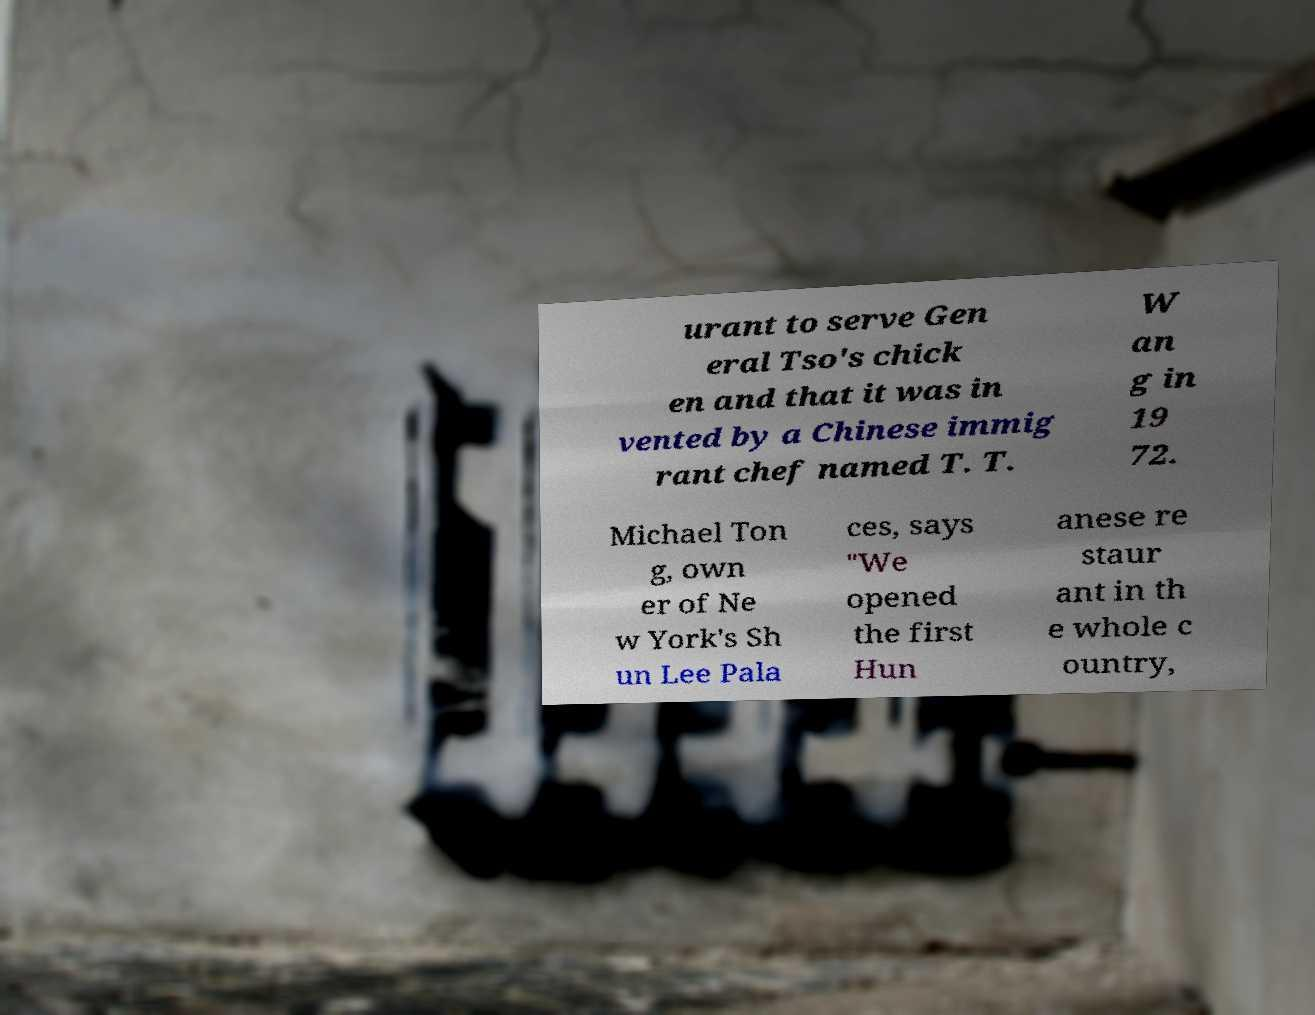Please identify and transcribe the text found in this image. urant to serve Gen eral Tso's chick en and that it was in vented by a Chinese immig rant chef named T. T. W an g in 19 72. Michael Ton g, own er of Ne w York's Sh un Lee Pala ces, says "We opened the first Hun anese re staur ant in th e whole c ountry, 